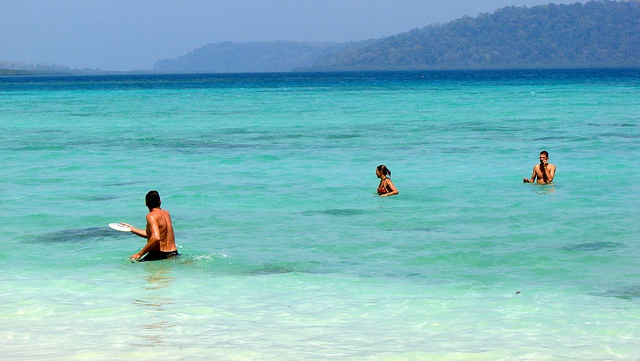Describe the objects in this image and their specific colors. I can see people in lightblue, black, brown, salmon, and maroon tones, people in lightblue, black, salmon, maroon, and brown tones, people in lightblue, black, maroon, brown, and salmon tones, and frisbee in lightblue, white, darkgray, olive, and beige tones in this image. 